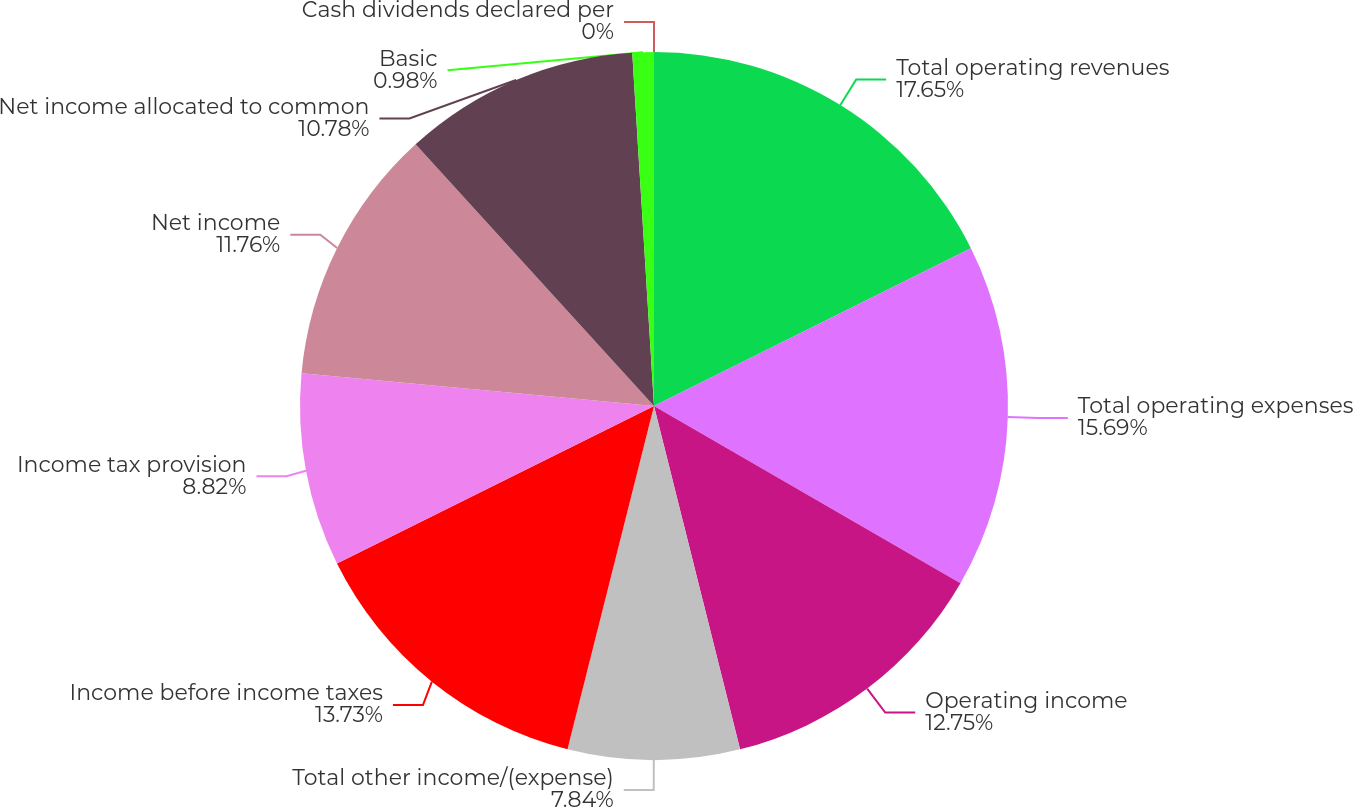<chart> <loc_0><loc_0><loc_500><loc_500><pie_chart><fcel>Total operating revenues<fcel>Total operating expenses<fcel>Operating income<fcel>Total other income/(expense)<fcel>Income before income taxes<fcel>Income tax provision<fcel>Net income<fcel>Net income allocated to common<fcel>Basic<fcel>Cash dividends declared per<nl><fcel>17.65%<fcel>15.69%<fcel>12.75%<fcel>7.84%<fcel>13.73%<fcel>8.82%<fcel>11.76%<fcel>10.78%<fcel>0.98%<fcel>0.0%<nl></chart> 